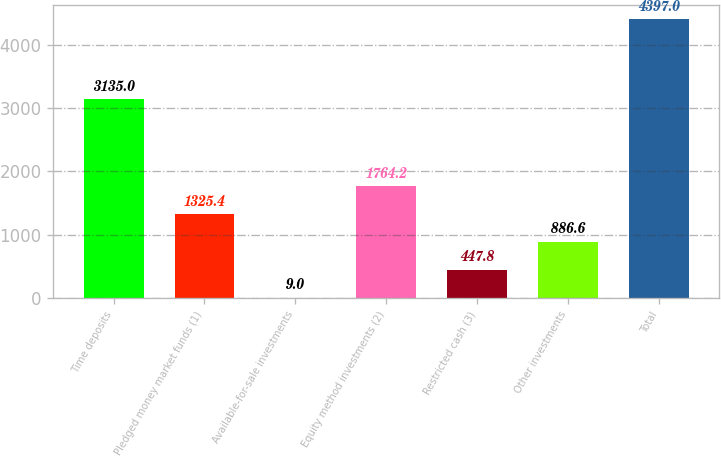<chart> <loc_0><loc_0><loc_500><loc_500><bar_chart><fcel>Time deposits<fcel>Pledged money market funds (1)<fcel>Available-for-sale investments<fcel>Equity method investments (2)<fcel>Restricted cash (3)<fcel>Other investments<fcel>Total<nl><fcel>3135<fcel>1325.4<fcel>9<fcel>1764.2<fcel>447.8<fcel>886.6<fcel>4397<nl></chart> 